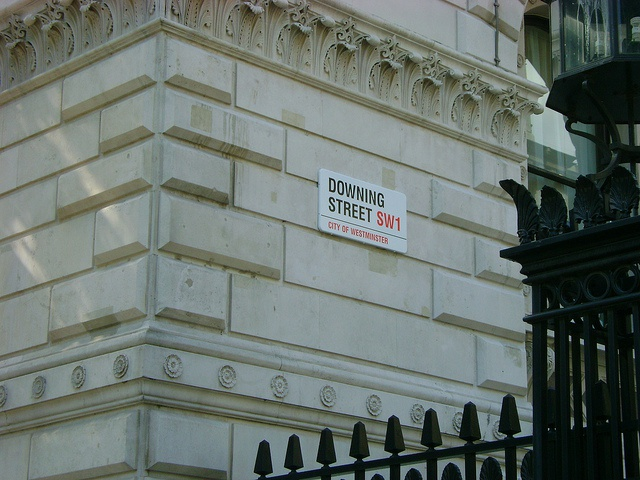Describe the objects in this image and their specific colors. I can see various objects in this image with different colors. 